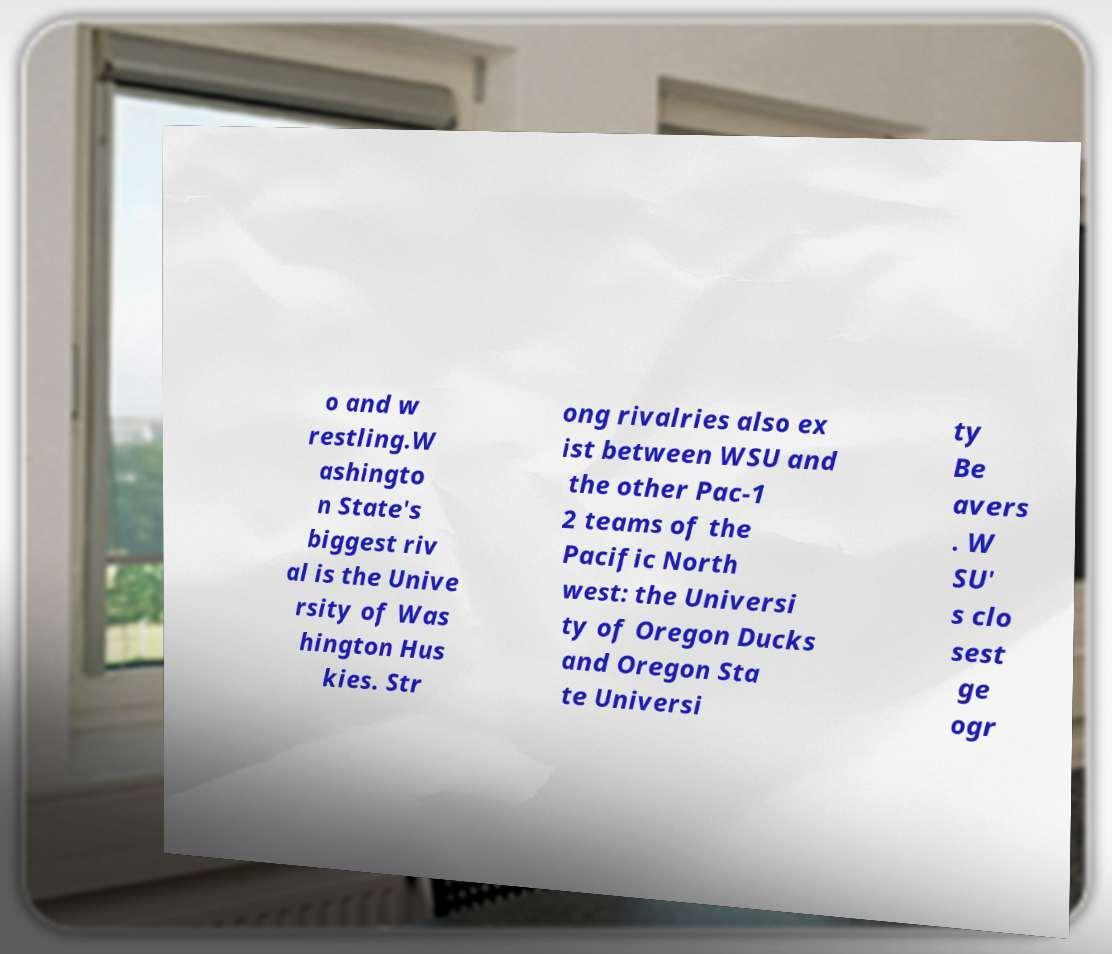Please read and relay the text visible in this image. What does it say? o and w restling.W ashingto n State's biggest riv al is the Unive rsity of Was hington Hus kies. Str ong rivalries also ex ist between WSU and the other Pac-1 2 teams of the Pacific North west: the Universi ty of Oregon Ducks and Oregon Sta te Universi ty Be avers . W SU' s clo sest ge ogr 